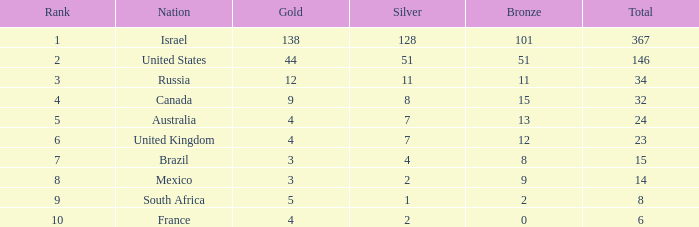What is the gold medal count for the country with a total greater than 32 and more than 128 silvers? None. 